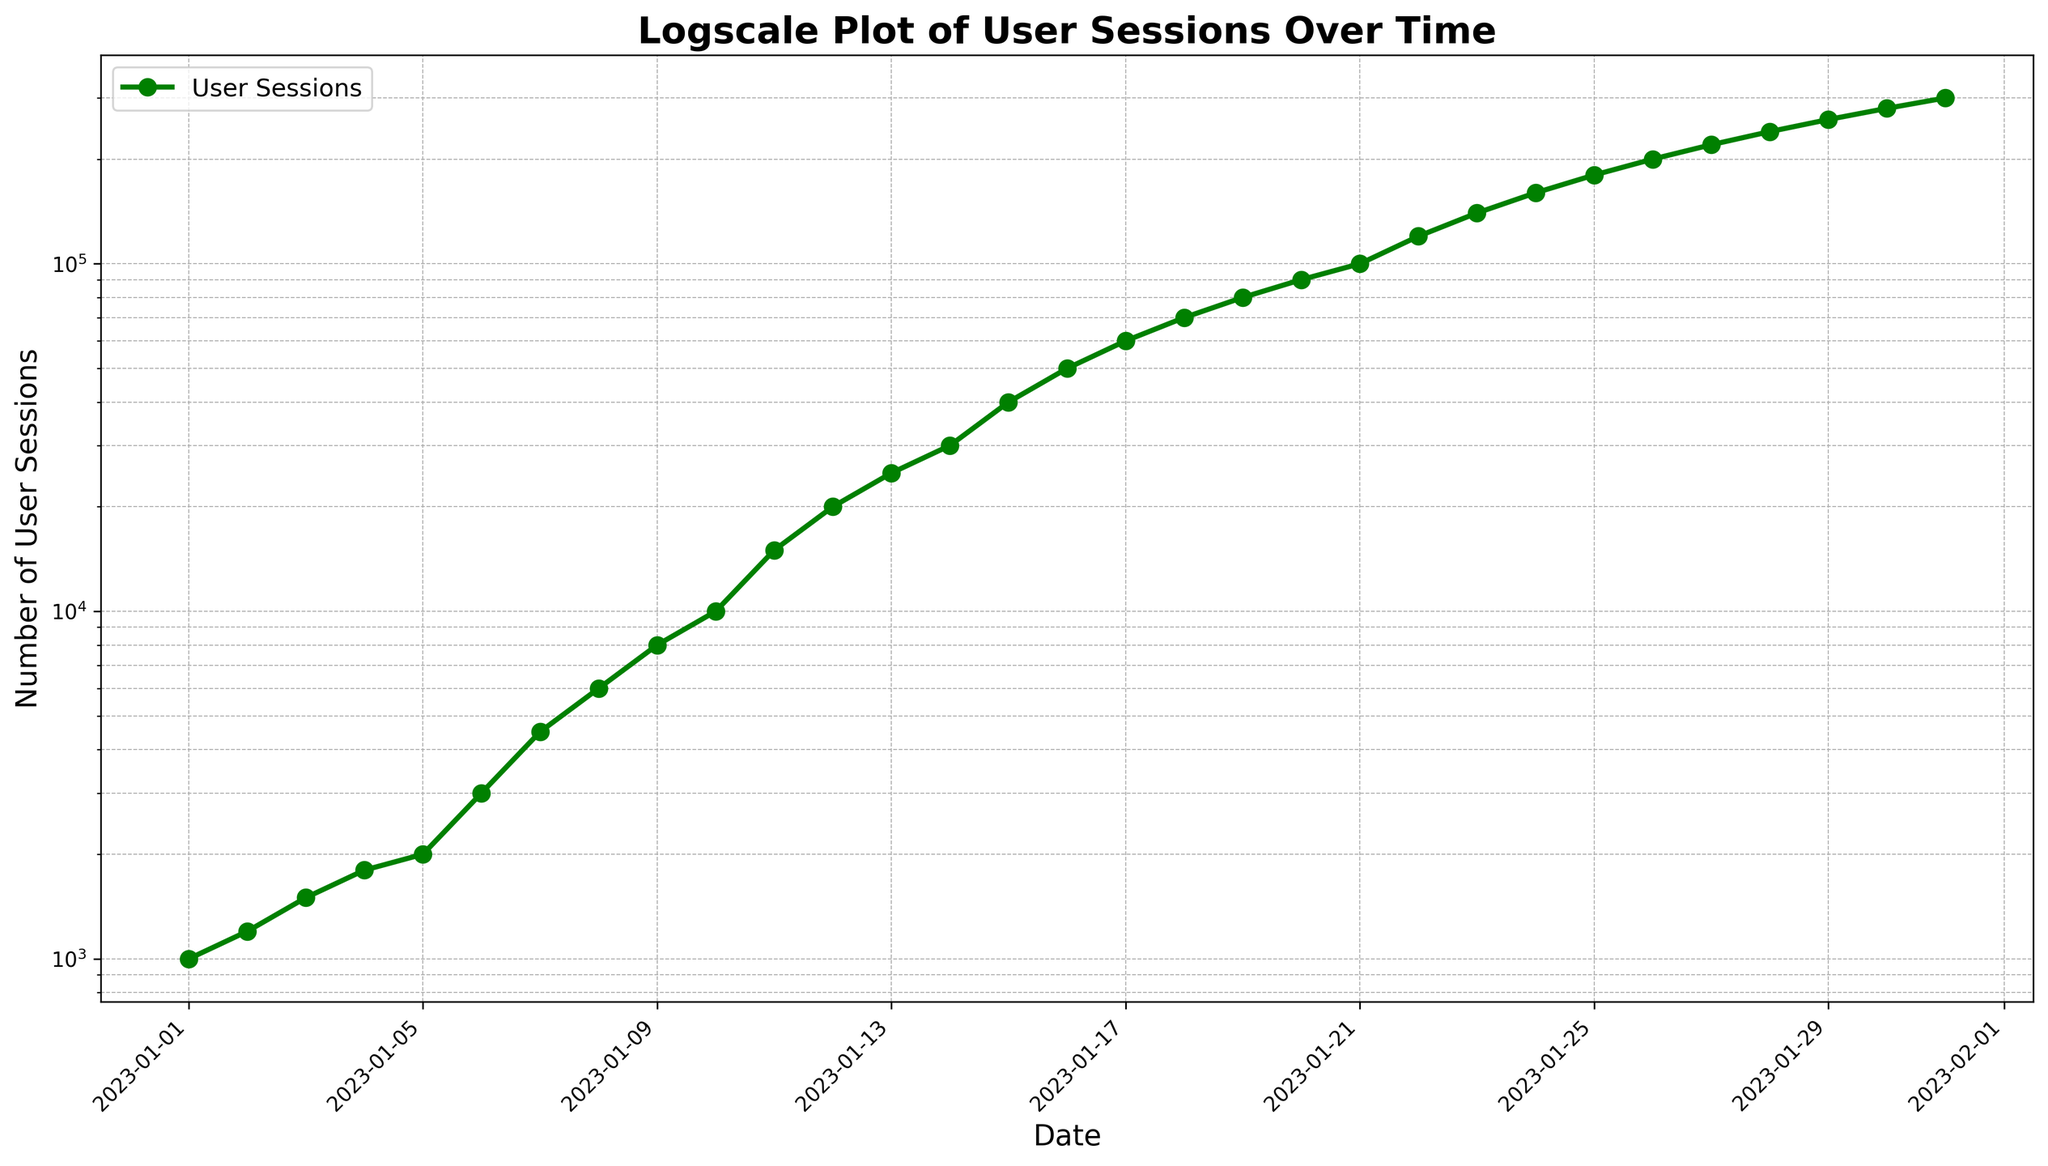What is the general trend of user sessions over time? Observing the plot, the number of user sessions consistently increases over time, with a rapid growth rate evident from the upward curve on the log scale. This indicates that the website traffic is experiencing exponential growth.
Answer: Exponential growth What is the approximate number of user sessions on January 20, 2023? To find the number of user sessions on January 20, 2023, locate the date on the x-axis and then trace vertically to the corresponding point on the plot. The value appears to be close to 90,000 user sessions.
Answer: 90,000 Between which two dates is the most significant increase in user sessions observed? By examining the plot, the segment between January 21, 2023, and January 22, 2023, appears to show the most significant vertical increase in user sessions, suggesting a substantial jump during this period.
Answer: January 21 and January 22 How does the user session count on January 31, 2023, compare to that on January 1, 2023? To compare, look at the start and end points of the plot. On January 1, 2023, there are about 1,000 user sessions, while on January 31, 2023, there are approximately 300,000 user sessions. The January 31 value is significantly higher.
Answer: Much higher What is the median number of user sessions over the entire period? The median is the middle value in a sorted list of numbers. With 31 data points, the median is the 16th value. The 16th date (January 16, 2023) has a user session count of 50,000. Thus, the median number of user sessions is 50,000.
Answer: 50,000 Which date marks the first time the number of user sessions reaches at least 100,000? Identify the point on the plot where the y-value first reaches or exceeds 100,000. This occurs on January 21, 2023.
Answer: January 21, 2023 How long did it take for the user sessions to grow from 10,000 to 100,000? Locate the dates corresponding to 10,000 and 100,000 user sessions. 10,000 user sessions were reached on January 10, 2023, and 100,000 user sessions on January 21, 2023. The time taken is 11 days.
Answer: 11 days What is the approximate number of user sessions on January 10, 2023, and January 15, 2023? Referring to the plot, on January 10, 2023, the number of user sessions is approximately 10,000. On January 15, 2023, the value is around 40,000.
Answer: 10,000 and 40,000 What is the rate of increase in user sessions from January 1, 2023, to January 31, 2023? The rate of increase is calculated by the difference in sessions divided by the number of days. From 1,000 to 300,000 sessions over 30 days results in a rate of (300,000 - 1,000) / 30 = 9,967 sessions per day approximately.
Answer: Approximately 9,967 sessions per day Which color is used to represent the user sessions line on the plot? The visual inspection of the plot indicates that the user sessions line is represented in a green color with circular markers.
Answer: Green 